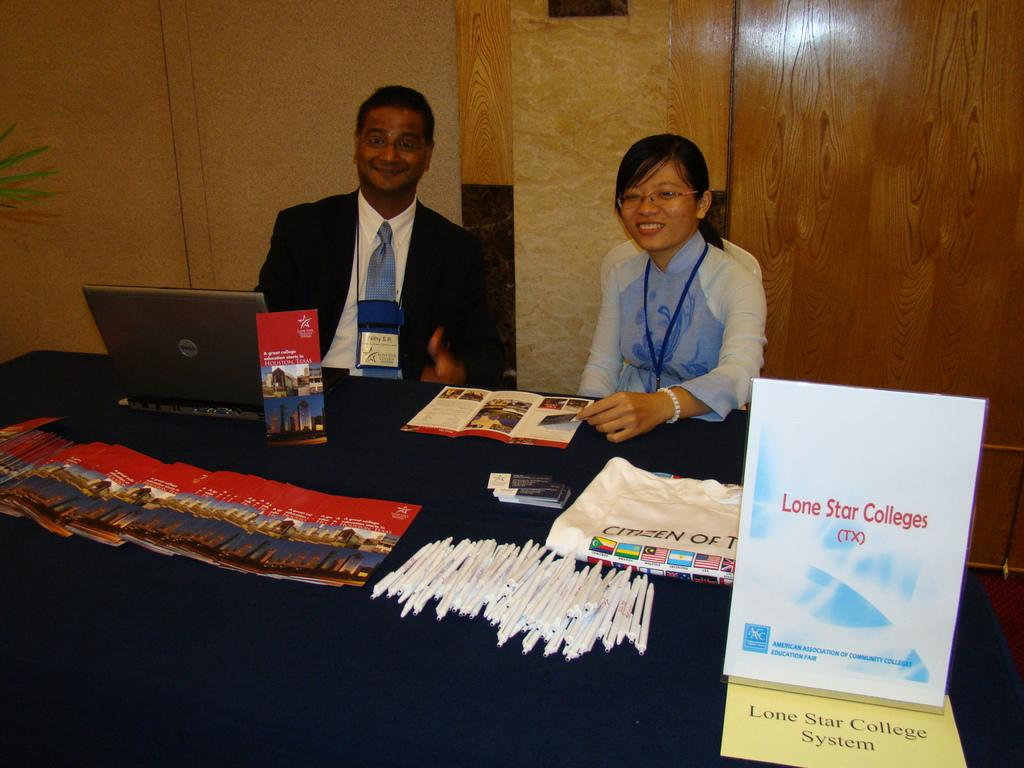<image>
Present a compact description of the photo's key features. 2 people standing behind a table calle dlone star colleges 